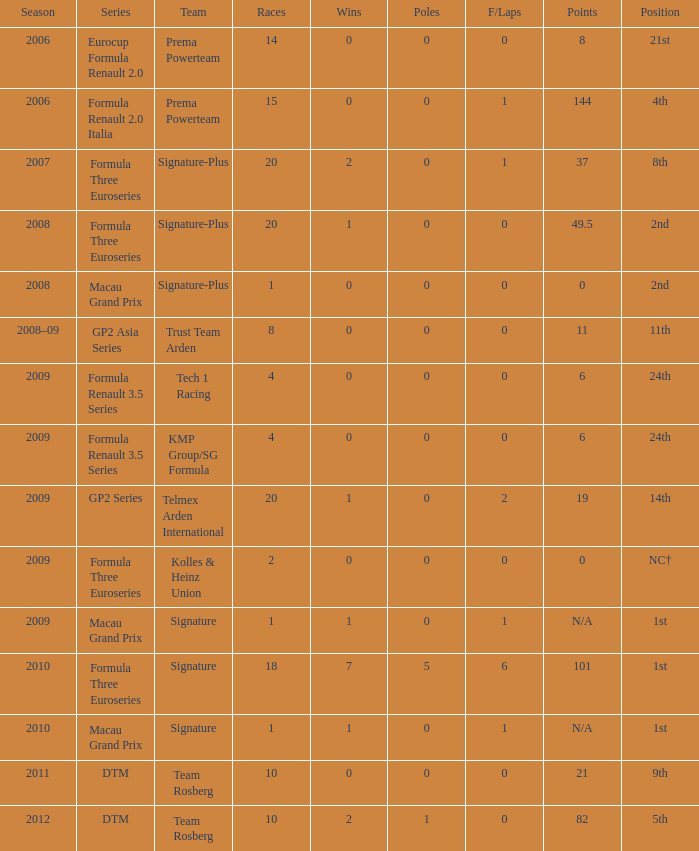How many poles are there in the Formula Three Euroseries in the 2008 season with more than 0 F/Laps? None. 